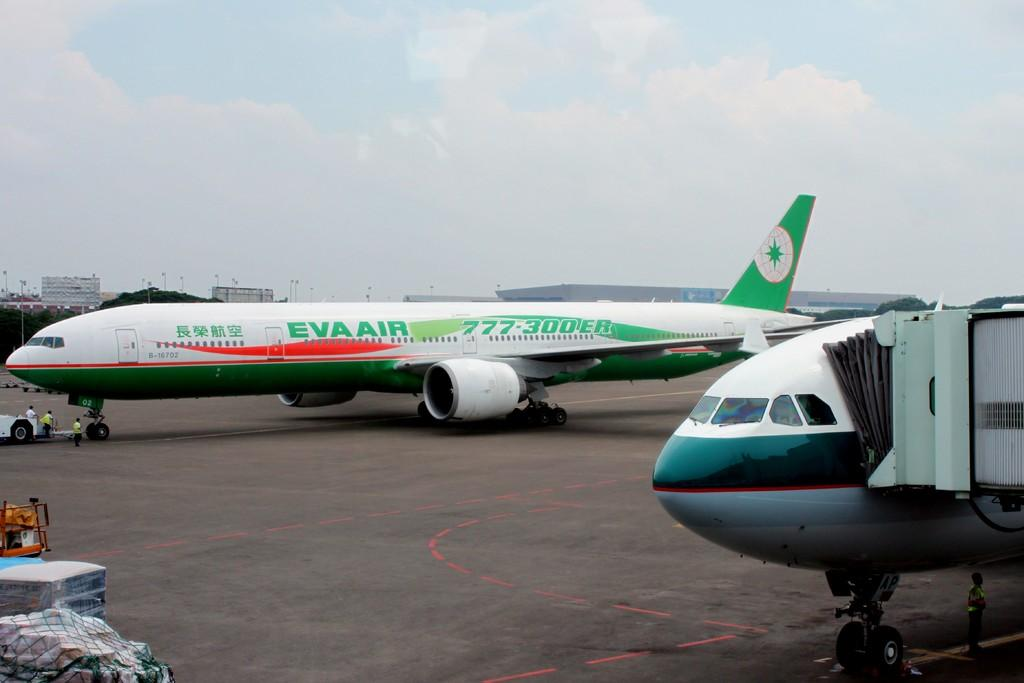<image>
Provide a brief description of the given image. A white and gree Eva AIr jet liner sits on an airport parking bay next to another plane which is being boarded. 